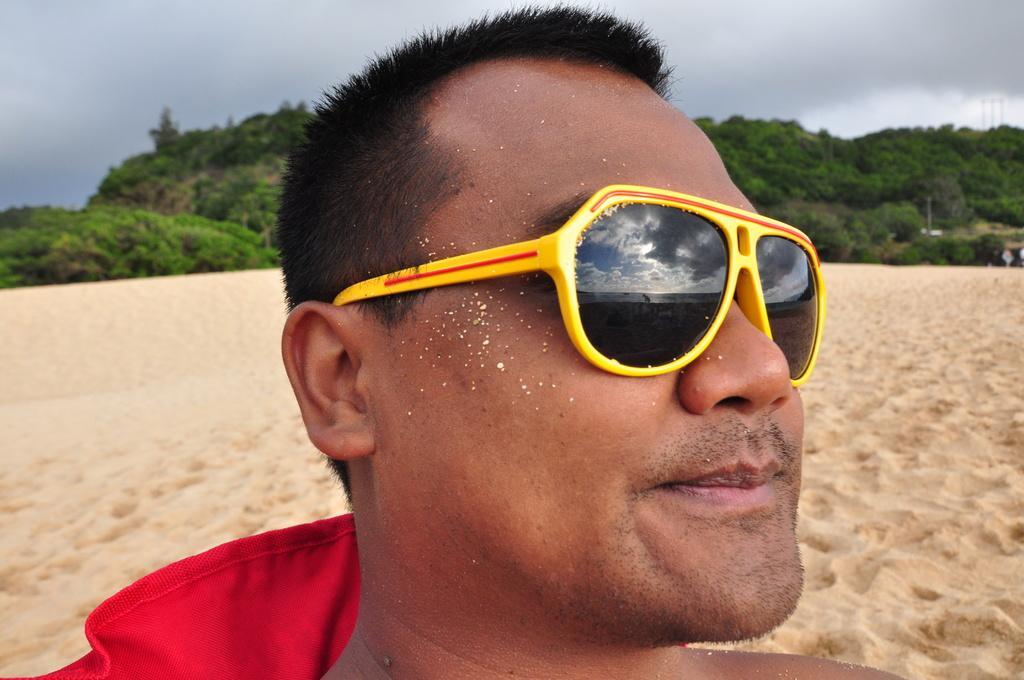Please provide a concise description of this image. In this image I can see a person is wearing specs and sand. In the background I can see trees, mountains, pillars, group of people and the sky. This image is taken may be during a day. 